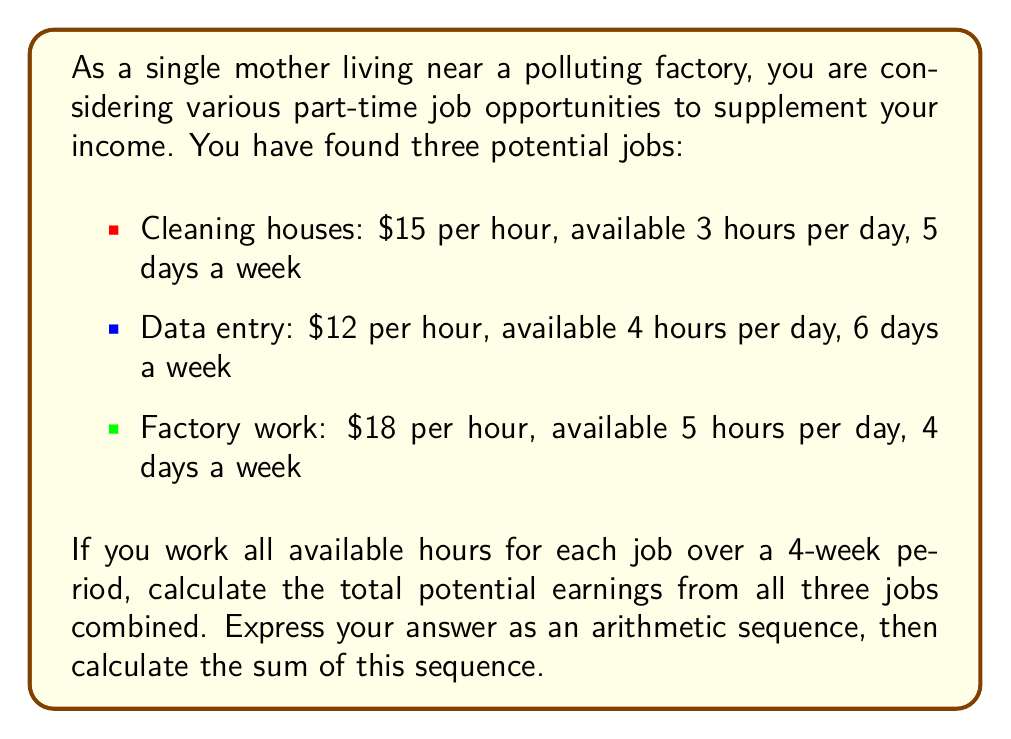Show me your answer to this math problem. Let's break this down step-by-step:

1. Calculate weekly earnings for each job:

   a. Cleaning houses: $15 * 3 hours * 5 days = $225 per week
   b. Data entry: $12 * 4 hours * 6 days = $288 per week
   c. Factory work: $18 * 5 hours * 4 days = $360 per week

2. Total weekly earnings: $225 + $288 + $360 = $873

3. Express the earnings over 4 weeks as an arithmetic sequence:

   The sequence will be: $873, $1746, $2619, $3492

   We can represent this as an arithmetic sequence:
   $a_n = a_1 + (n-1)d$

   Where:
   $a_1 = 873$ (first term)
   $d = 873$ (common difference)
   $n = 4$ (number of terms)

4. To calculate the sum of this arithmetic sequence, we can use the formula:

   $S_n = \frac{n}{2}(a_1 + a_n)$

   Where:
   $S_n$ is the sum of the sequence
   $n = 4$ (number of terms)
   $a_1 = 873$ (first term)
   $a_n = a_4 = 873 + (4-1)873 = 3492$ (last term)

5. Plugging these values into the formula:

   $S_4 = \frac{4}{2}(873 + 3492)$
   $S_4 = 2(4365)$
   $S_4 = 8730$

Therefore, the total potential earnings from all three jobs over a 4-week period is $8730.
Answer: $8730 